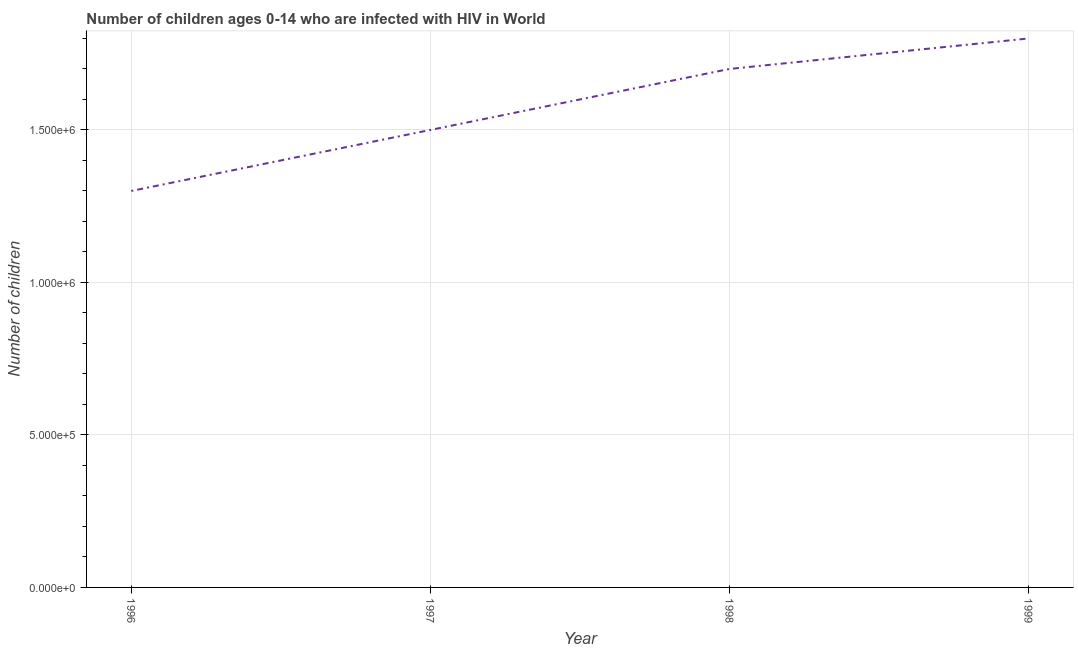What is the number of children living with hiv in 1998?
Make the answer very short. 1.70e+06. Across all years, what is the maximum number of children living with hiv?
Your response must be concise. 1.80e+06. Across all years, what is the minimum number of children living with hiv?
Keep it short and to the point. 1.30e+06. In which year was the number of children living with hiv maximum?
Offer a terse response. 1999. In which year was the number of children living with hiv minimum?
Give a very brief answer. 1996. What is the sum of the number of children living with hiv?
Your response must be concise. 6.30e+06. What is the difference between the number of children living with hiv in 1996 and 1998?
Ensure brevity in your answer.  -4.00e+05. What is the average number of children living with hiv per year?
Your answer should be compact. 1.58e+06. What is the median number of children living with hiv?
Provide a short and direct response. 1.60e+06. Do a majority of the years between 1999 and 1997 (inclusive) have number of children living with hiv greater than 1300000 ?
Your answer should be very brief. No. What is the ratio of the number of children living with hiv in 1998 to that in 1999?
Keep it short and to the point. 0.94. Is the number of children living with hiv in 1996 less than that in 1999?
Your answer should be very brief. Yes. What is the difference between the highest and the second highest number of children living with hiv?
Offer a very short reply. 1.00e+05. What is the difference between the highest and the lowest number of children living with hiv?
Give a very brief answer. 5.00e+05. Does the number of children living with hiv monotonically increase over the years?
Offer a very short reply. Yes. What is the difference between two consecutive major ticks on the Y-axis?
Ensure brevity in your answer.  5.00e+05. Does the graph contain any zero values?
Your answer should be very brief. No. What is the title of the graph?
Give a very brief answer. Number of children ages 0-14 who are infected with HIV in World. What is the label or title of the Y-axis?
Make the answer very short. Number of children. What is the Number of children of 1996?
Keep it short and to the point. 1.30e+06. What is the Number of children in 1997?
Your answer should be compact. 1.50e+06. What is the Number of children of 1998?
Offer a terse response. 1.70e+06. What is the Number of children in 1999?
Your answer should be compact. 1.80e+06. What is the difference between the Number of children in 1996 and 1998?
Offer a terse response. -4.00e+05. What is the difference between the Number of children in 1996 and 1999?
Give a very brief answer. -5.00e+05. What is the difference between the Number of children in 1997 and 1998?
Make the answer very short. -2.00e+05. What is the difference between the Number of children in 1997 and 1999?
Your answer should be compact. -3.00e+05. What is the ratio of the Number of children in 1996 to that in 1997?
Your answer should be very brief. 0.87. What is the ratio of the Number of children in 1996 to that in 1998?
Your response must be concise. 0.77. What is the ratio of the Number of children in 1996 to that in 1999?
Make the answer very short. 0.72. What is the ratio of the Number of children in 1997 to that in 1998?
Offer a terse response. 0.88. What is the ratio of the Number of children in 1997 to that in 1999?
Your response must be concise. 0.83. What is the ratio of the Number of children in 1998 to that in 1999?
Your answer should be very brief. 0.94. 